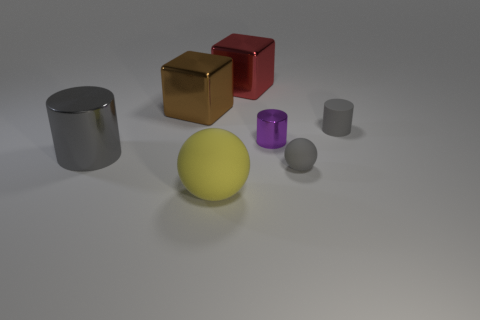Subtract all gray cylinders. How many cylinders are left? 1 Subtract all gray cylinders. How many cylinders are left? 1 Subtract all cylinders. How many objects are left? 4 Add 3 large yellow rubber cylinders. How many objects exist? 10 Subtract 1 cylinders. How many cylinders are left? 2 Subtract all cyan blocks. How many cyan cylinders are left? 0 Subtract all brown spheres. Subtract all brown cubes. How many spheres are left? 2 Subtract all large yellow balls. Subtract all rubber cylinders. How many objects are left? 5 Add 3 big gray things. How many big gray things are left? 4 Add 3 small gray cylinders. How many small gray cylinders exist? 4 